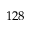<formula> <loc_0><loc_0><loc_500><loc_500>1 2 8</formula> 